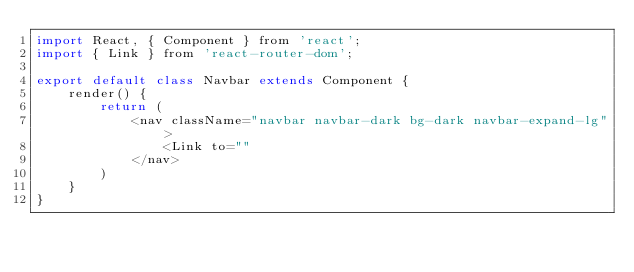Convert code to text. <code><loc_0><loc_0><loc_500><loc_500><_JavaScript_>import React, { Component } from 'react';
import { Link } from 'react-router-dom';

export default class Navbar extends Component {
    render() {
        return ( 
            <nav className="navbar navbar-dark bg-dark navbar-expand-lg">
                <Link to=""
            </nav>
        )
    }
}</code> 